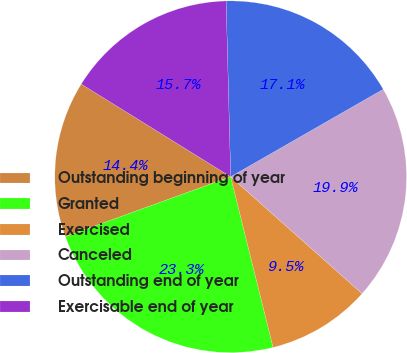<chart> <loc_0><loc_0><loc_500><loc_500><pie_chart><fcel>Outstanding beginning of year<fcel>Granted<fcel>Exercised<fcel>Canceled<fcel>Outstanding end of year<fcel>Exercisable end of year<nl><fcel>14.37%<fcel>23.35%<fcel>9.55%<fcel>19.86%<fcel>17.13%<fcel>15.75%<nl></chart> 